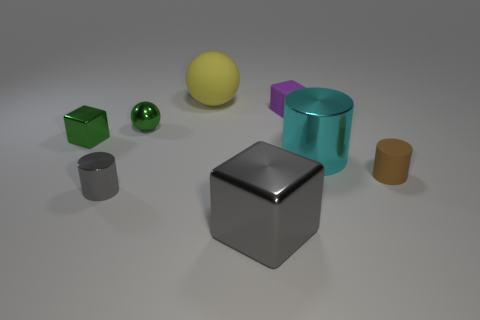Are there any shiny blocks of the same color as the metal ball?
Offer a very short reply. Yes. Are there any tiny rubber balls?
Your answer should be very brief. No. Is the tiny cylinder that is on the left side of the small rubber cube made of the same material as the large sphere?
Your response must be concise. No. The thing that is the same color as the tiny metallic cylinder is what size?
Keep it short and to the point. Large. What number of green metallic objects are the same size as the green ball?
Your response must be concise. 1. Are there an equal number of big cyan cylinders that are behind the green block and small blue metal cylinders?
Provide a succinct answer. Yes. What number of large things are both in front of the big yellow rubber ball and left of the cyan object?
Make the answer very short. 1. There is a gray cylinder that is the same material as the large block; what size is it?
Ensure brevity in your answer.  Small. How many brown rubber things have the same shape as the cyan thing?
Give a very brief answer. 1. Is the number of things that are behind the brown rubber cylinder greater than the number of small shiny balls?
Your answer should be compact. Yes. 